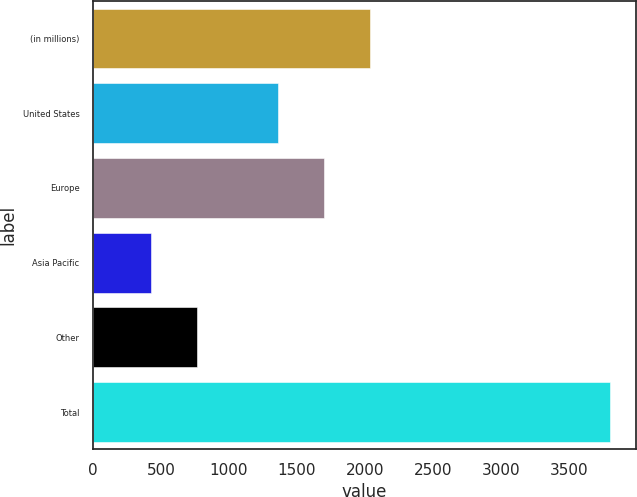<chart> <loc_0><loc_0><loc_500><loc_500><bar_chart><fcel>(in millions)<fcel>United States<fcel>Europe<fcel>Asia Pacific<fcel>Other<fcel>Total<nl><fcel>2038.4<fcel>1363<fcel>1700.7<fcel>426<fcel>763.7<fcel>3803<nl></chart> 